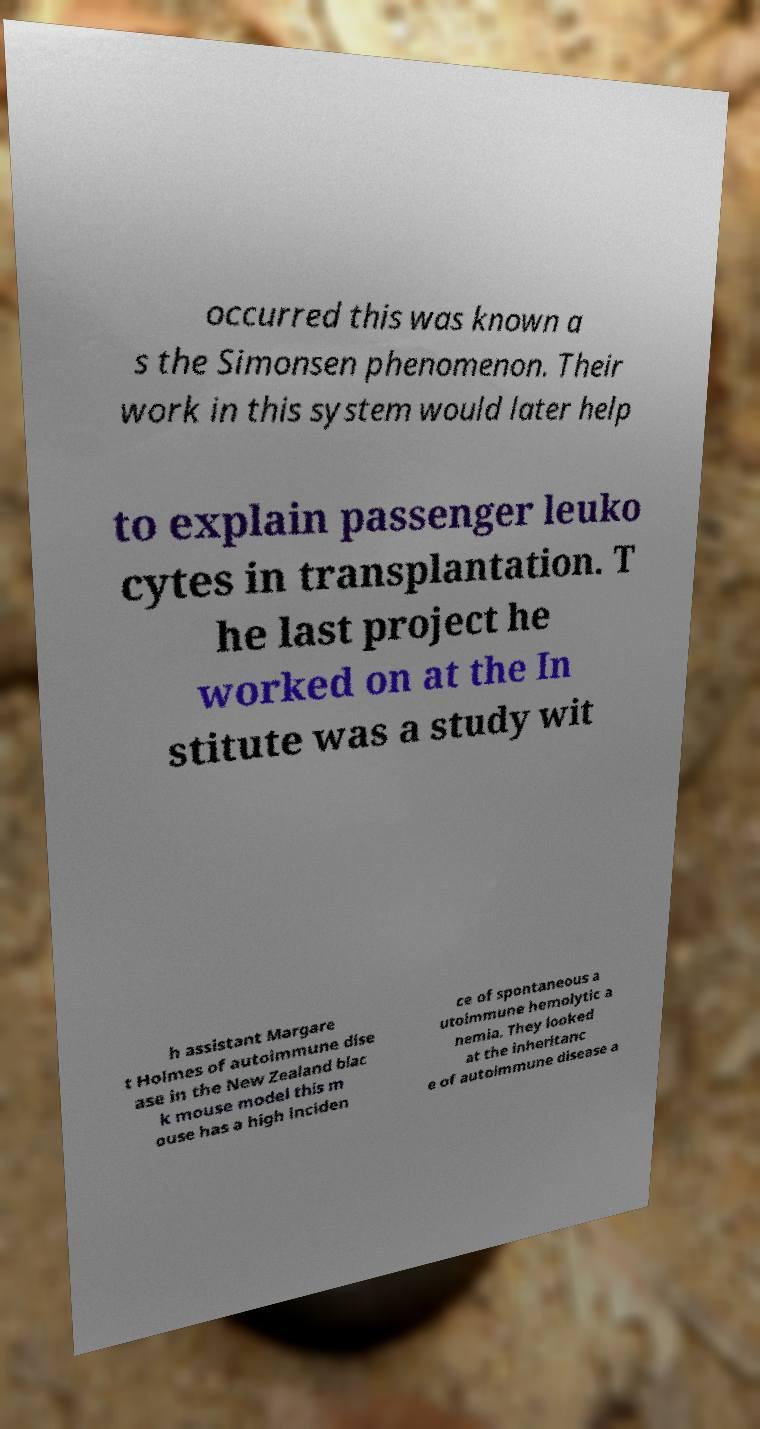For documentation purposes, I need the text within this image transcribed. Could you provide that? occurred this was known a s the Simonsen phenomenon. Their work in this system would later help to explain passenger leuko cytes in transplantation. T he last project he worked on at the In stitute was a study wit h assistant Margare t Holmes of autoimmune dise ase in the New Zealand blac k mouse model this m ouse has a high inciden ce of spontaneous a utoimmune hemolytic a nemia. They looked at the inheritanc e of autoimmune disease a 